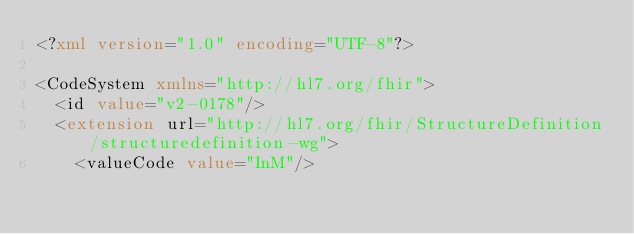Convert code to text. <code><loc_0><loc_0><loc_500><loc_500><_XML_><?xml version="1.0" encoding="UTF-8"?>

<CodeSystem xmlns="http://hl7.org/fhir">
  <id value="v2-0178"/>
  <extension url="http://hl7.org/fhir/StructureDefinition/structuredefinition-wg">
    <valueCode value="InM"/></code> 